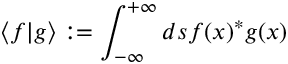<formula> <loc_0><loc_0><loc_500><loc_500>\langle f | g \rangle \colon = \int _ { - \infty } ^ { + \infty } d s f ( x ) ^ { * } g ( x )</formula> 